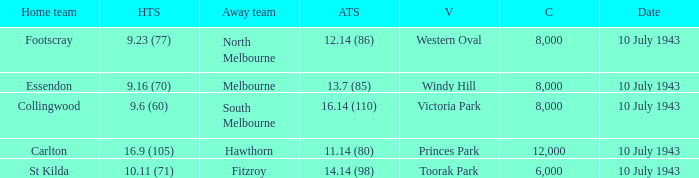When the Away team scored 14.14 (98), which Venue did the game take place? Toorak Park. 